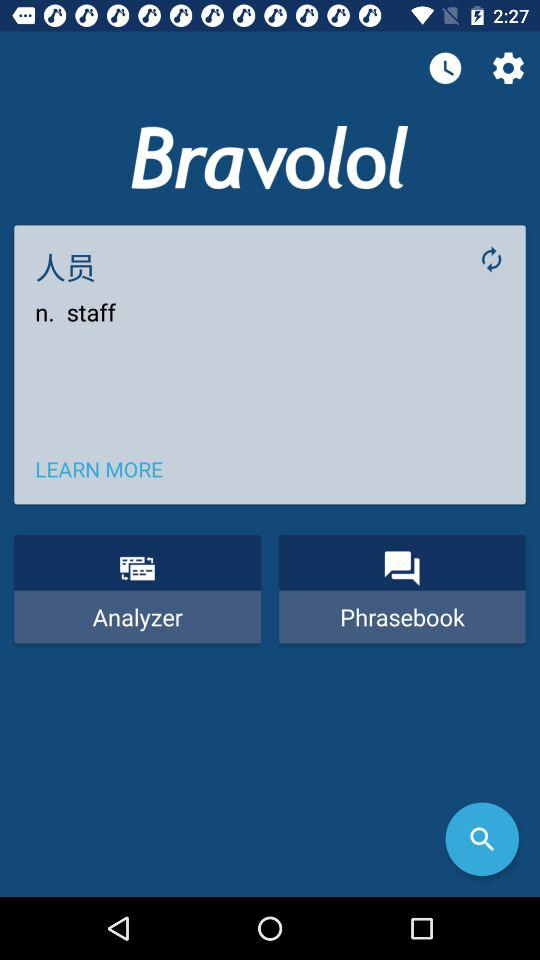What is the application name?
When the provided information is insufficient, respond with <no answer>. <no answer> 